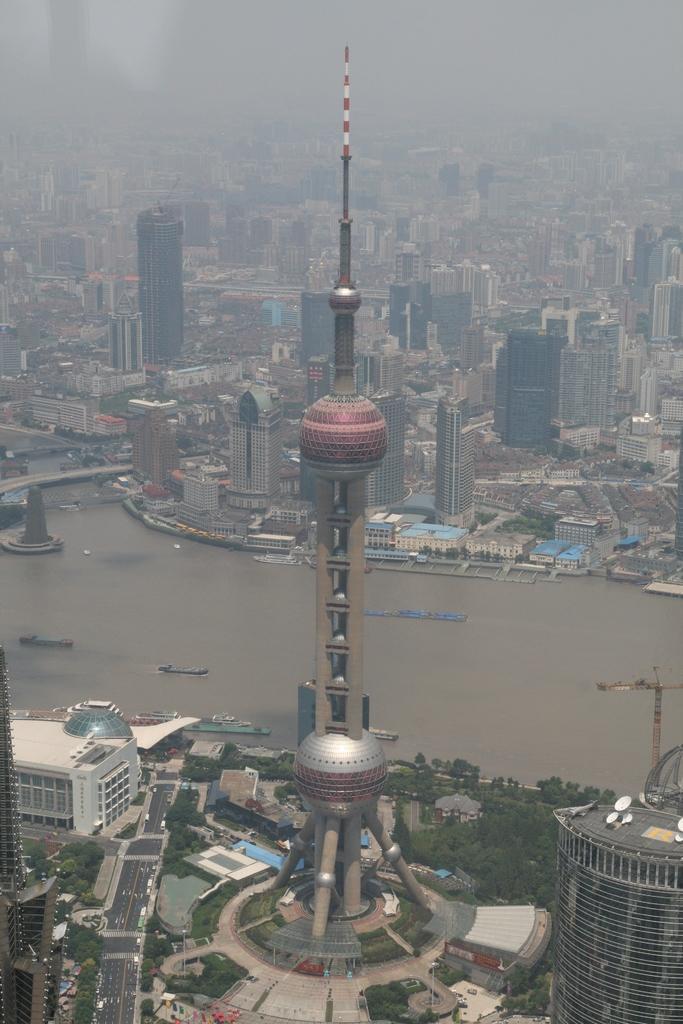Can you describe this image briefly? At the bottom of the picture, we see a tower, buildings and trees. In the middle of the picture, we see water and boats are sailing on the water. On the left side, we see a bridge. There are building in the background. At the top of the picture, it is blurred. 